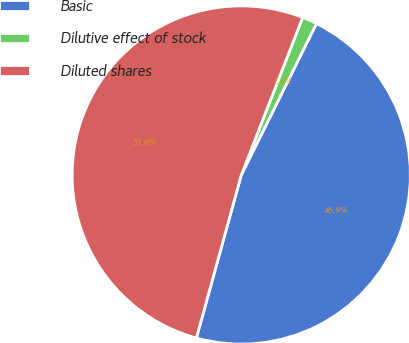<chart> <loc_0><loc_0><loc_500><loc_500><pie_chart><fcel>Basic<fcel>Dilutive effect of stock<fcel>Diluted shares<nl><fcel>46.94%<fcel>1.42%<fcel>51.64%<nl></chart> 